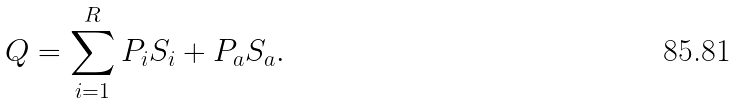Convert formula to latex. <formula><loc_0><loc_0><loc_500><loc_500>Q = \sum _ { i = 1 } ^ { R } P _ { i } S _ { i } + P _ { a } S _ { a } .</formula> 